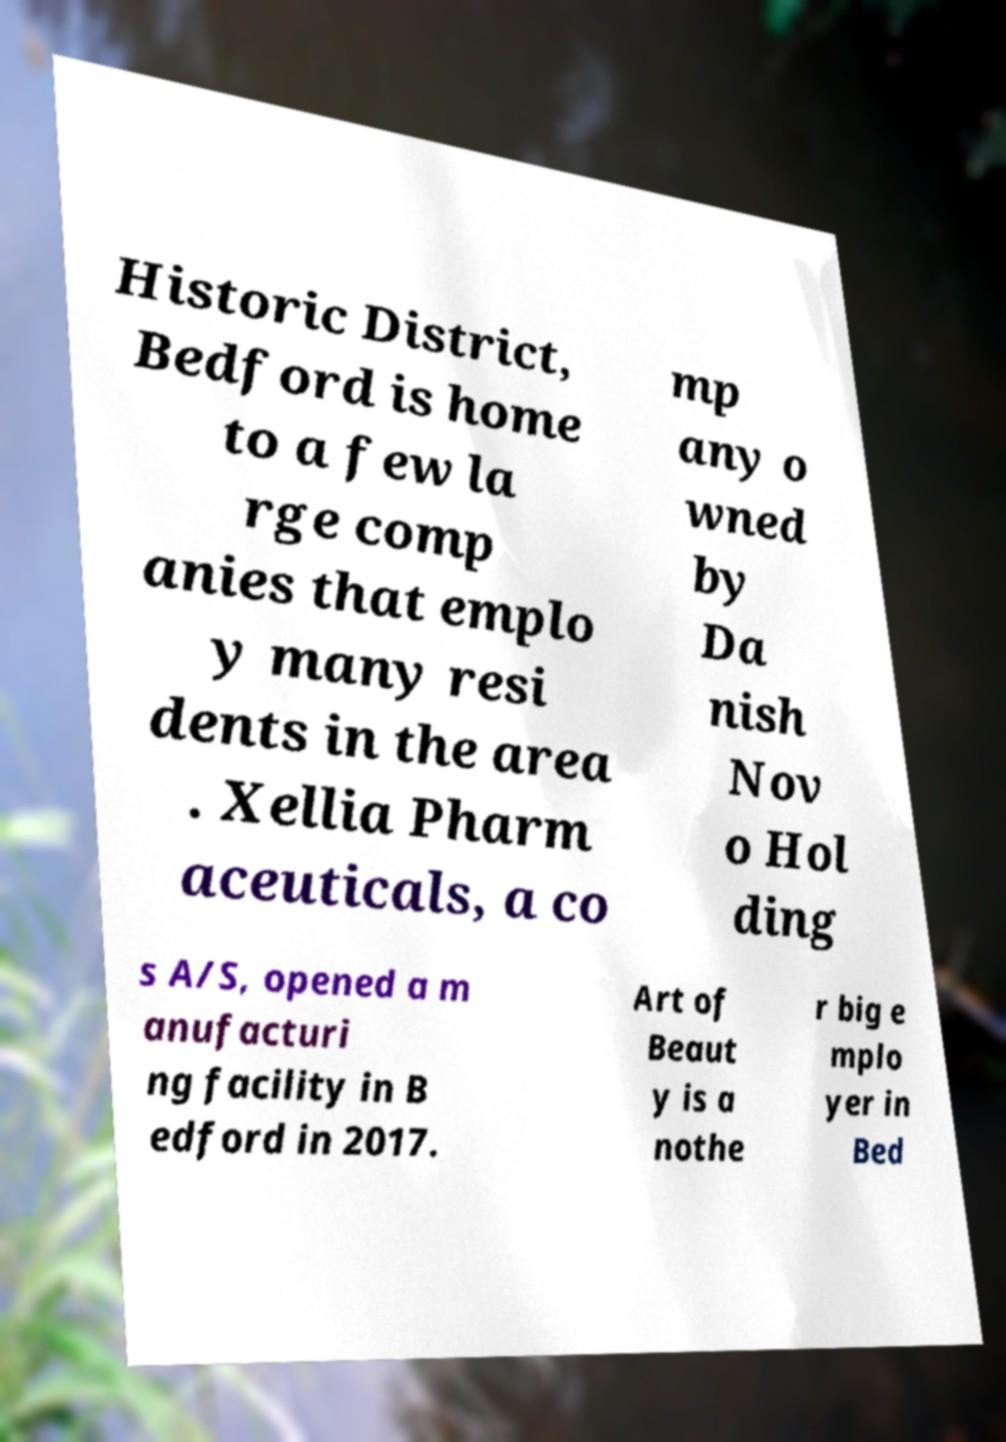What messages or text are displayed in this image? I need them in a readable, typed format. Historic District, Bedford is home to a few la rge comp anies that emplo y many resi dents in the area . Xellia Pharm aceuticals, a co mp any o wned by Da nish Nov o Hol ding s A/S, opened a m anufacturi ng facility in B edford in 2017. Art of Beaut y is a nothe r big e mplo yer in Bed 